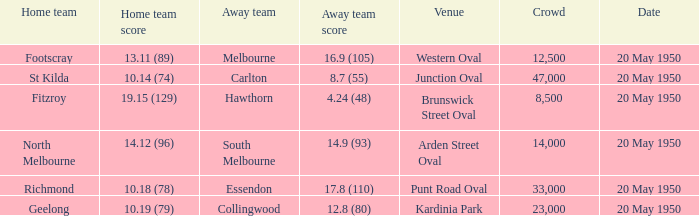What was the score for the away team when the home team was Fitzroy? 4.24 (48). 